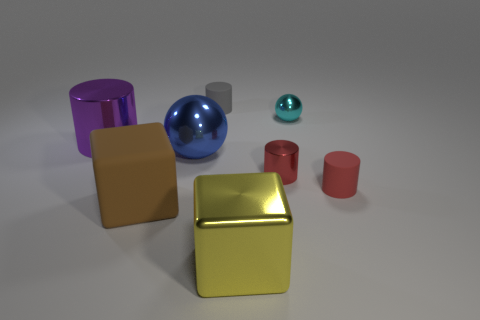How many objects are small objects or objects that are right of the large brown block?
Your answer should be compact. 6. The large metallic ball is what color?
Keep it short and to the point. Blue. What is the color of the small cylinder that is to the left of the yellow metallic block?
Your answer should be compact. Gray. How many spheres are right of the shiny cylinder that is to the right of the large matte block?
Your response must be concise. 1. Is the size of the cyan sphere the same as the yellow object that is in front of the tiny gray rubber thing?
Give a very brief answer. No. Is there a blue object that has the same size as the cyan metal sphere?
Your answer should be compact. No. What number of objects are metal objects or tiny blocks?
Give a very brief answer. 5. Is the size of the brown object in front of the purple thing the same as the blue shiny ball behind the small red metal cylinder?
Provide a succinct answer. Yes. Are there any red things of the same shape as the cyan metal object?
Keep it short and to the point. No. Are there fewer small cyan spheres that are on the right side of the big yellow object than gray cylinders?
Provide a short and direct response. No. 